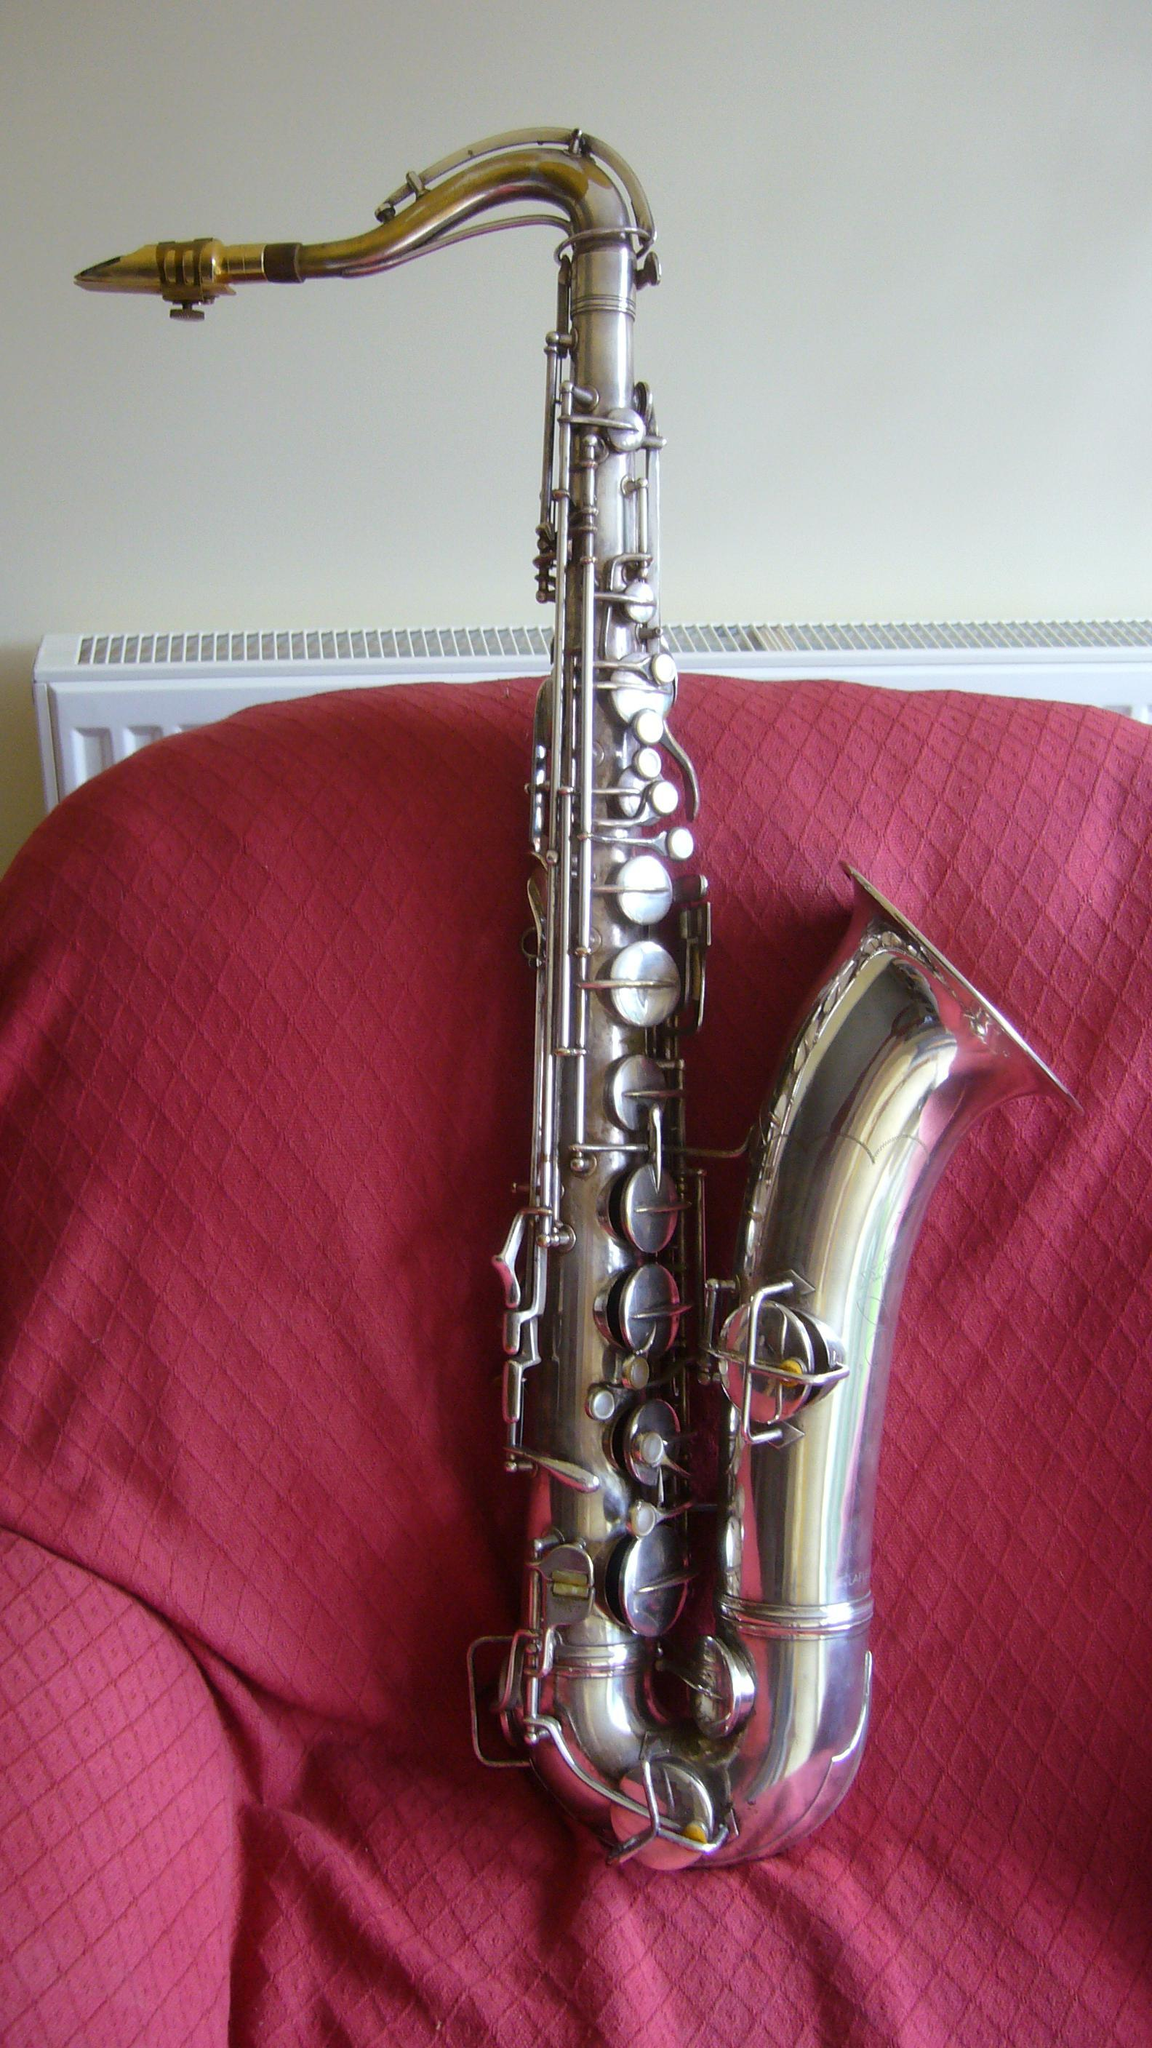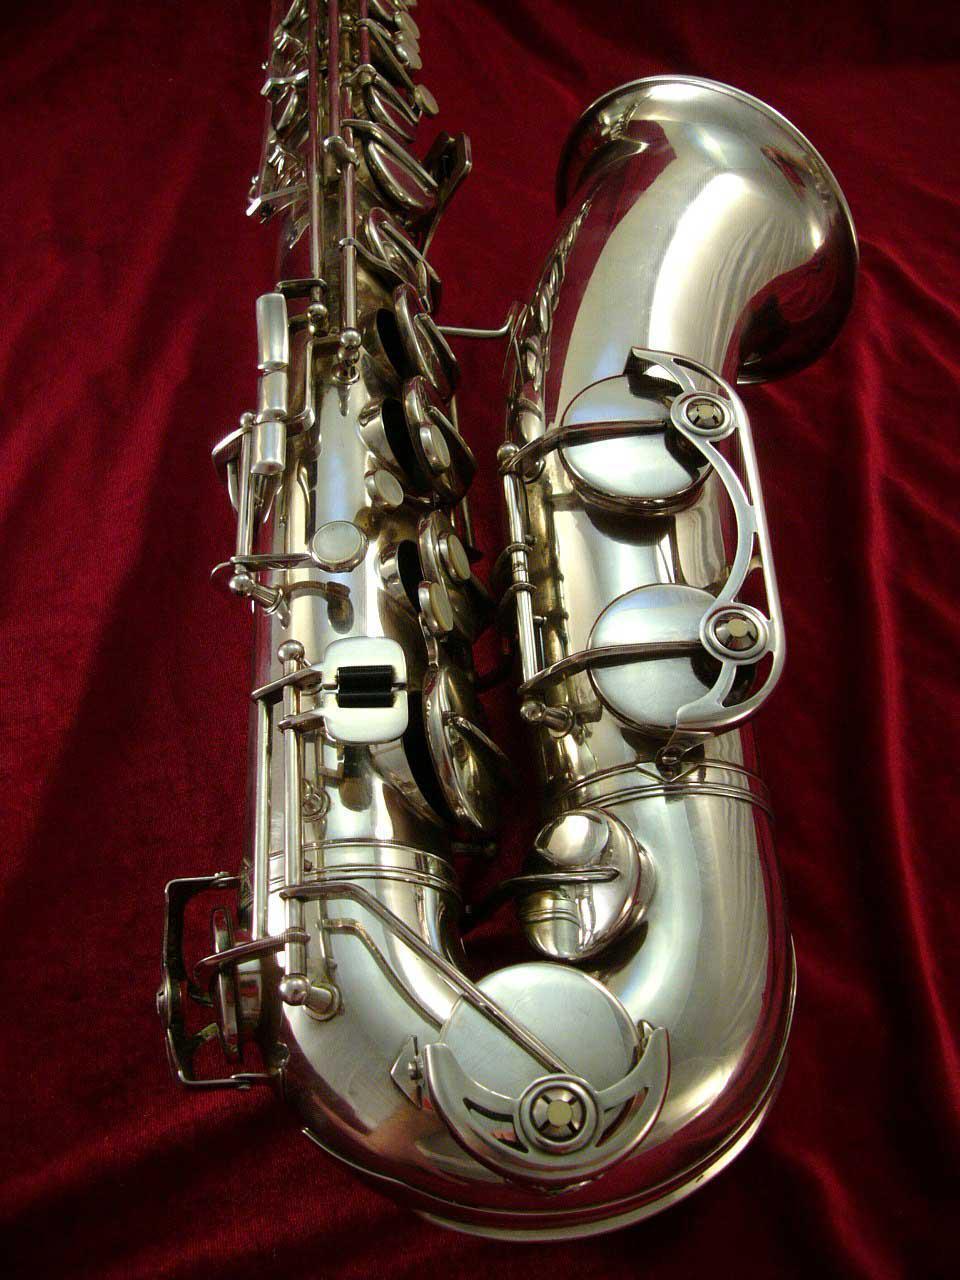The first image is the image on the left, the second image is the image on the right. For the images displayed, is the sentence "Right image shows a saxophone with a decorative etching on the exterior of its bell end." factually correct? Answer yes or no. No. The first image is the image on the left, the second image is the image on the right. Given the left and right images, does the statement "The mouthpiece of a saxophone in one image arcs in a curve and then straightens so that it is perpendicular to the instrument body." hold true? Answer yes or no. Yes. 